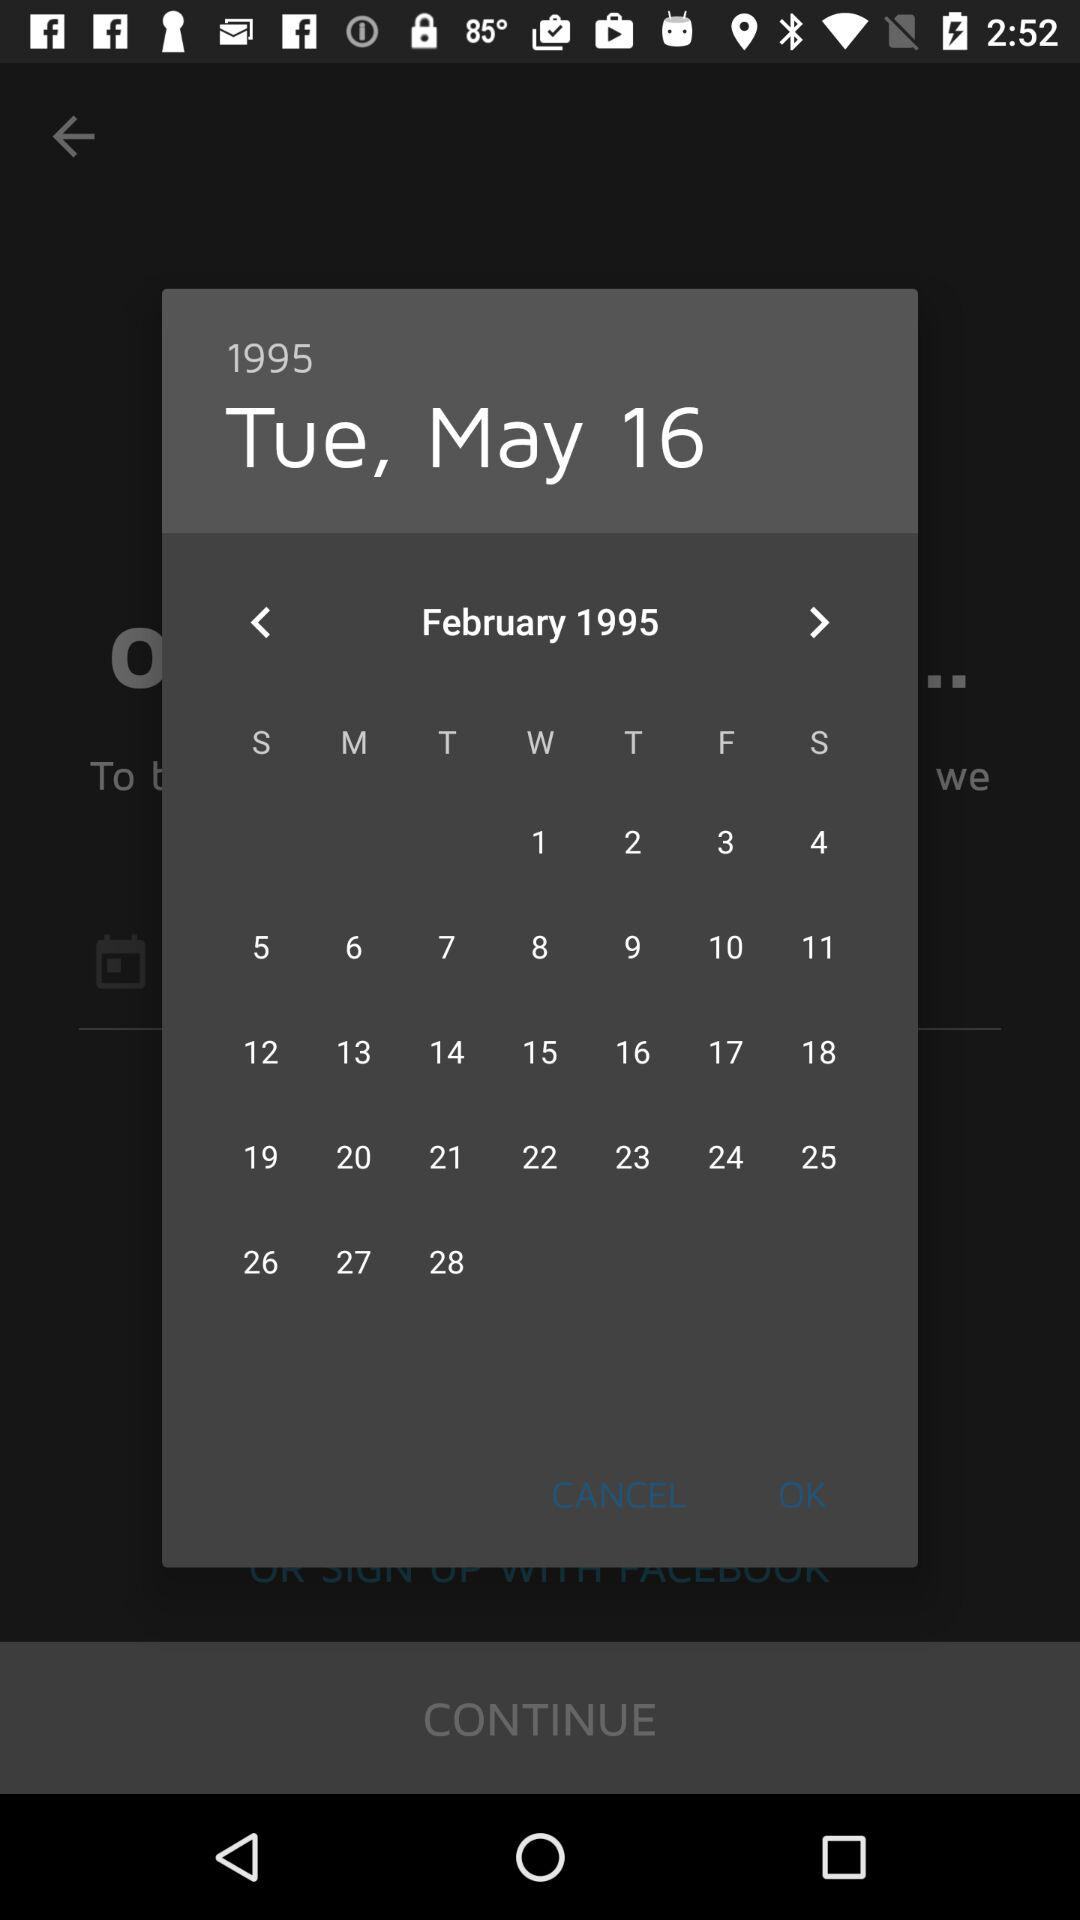What is the day on May 16, 1995? The day is Tuesday. 